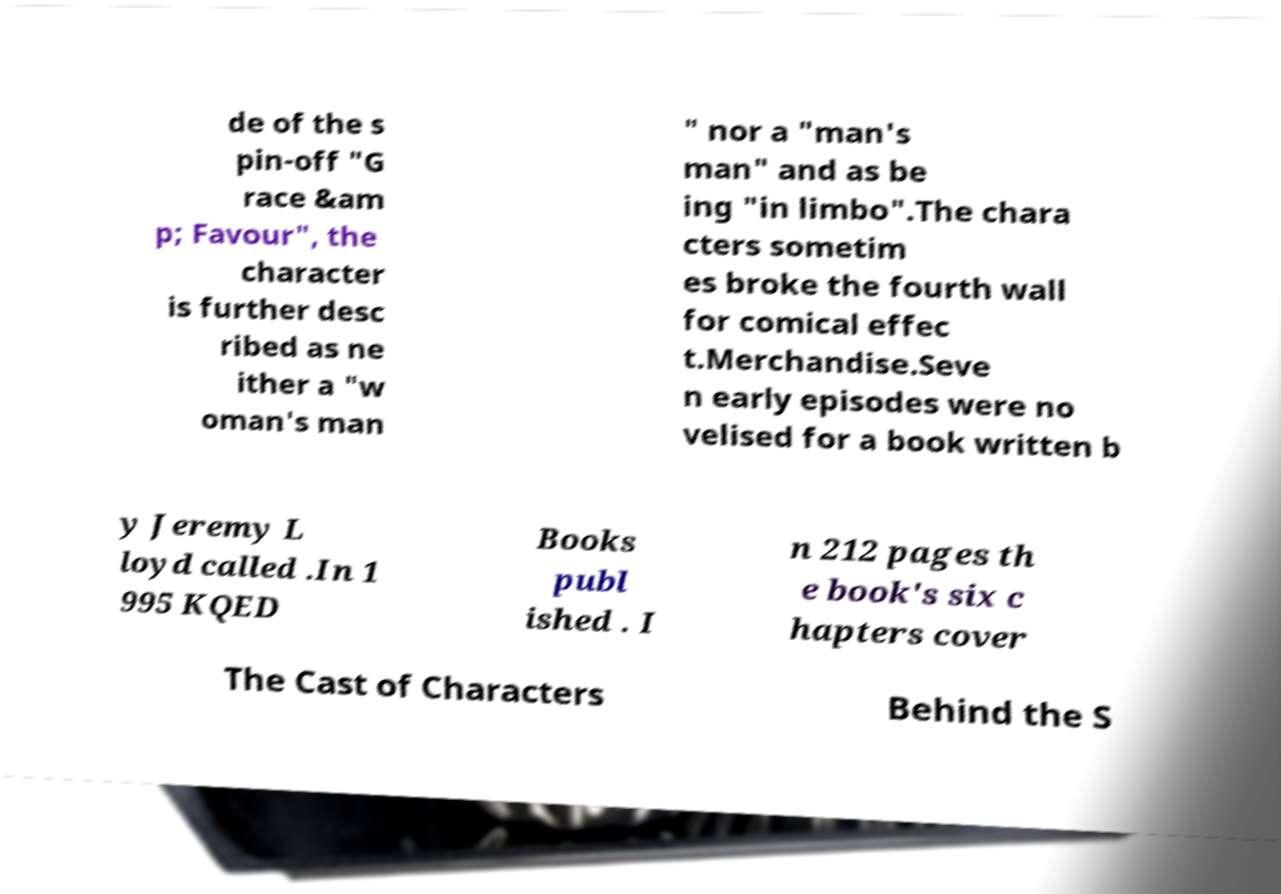I need the written content from this picture converted into text. Can you do that? de of the s pin-off "G race &am p; Favour", the character is further desc ribed as ne ither a "w oman's man " nor a "man's man" and as be ing "in limbo".The chara cters sometim es broke the fourth wall for comical effec t.Merchandise.Seve n early episodes were no velised for a book written b y Jeremy L loyd called .In 1 995 KQED Books publ ished . I n 212 pages th e book's six c hapters cover The Cast of Characters Behind the S 